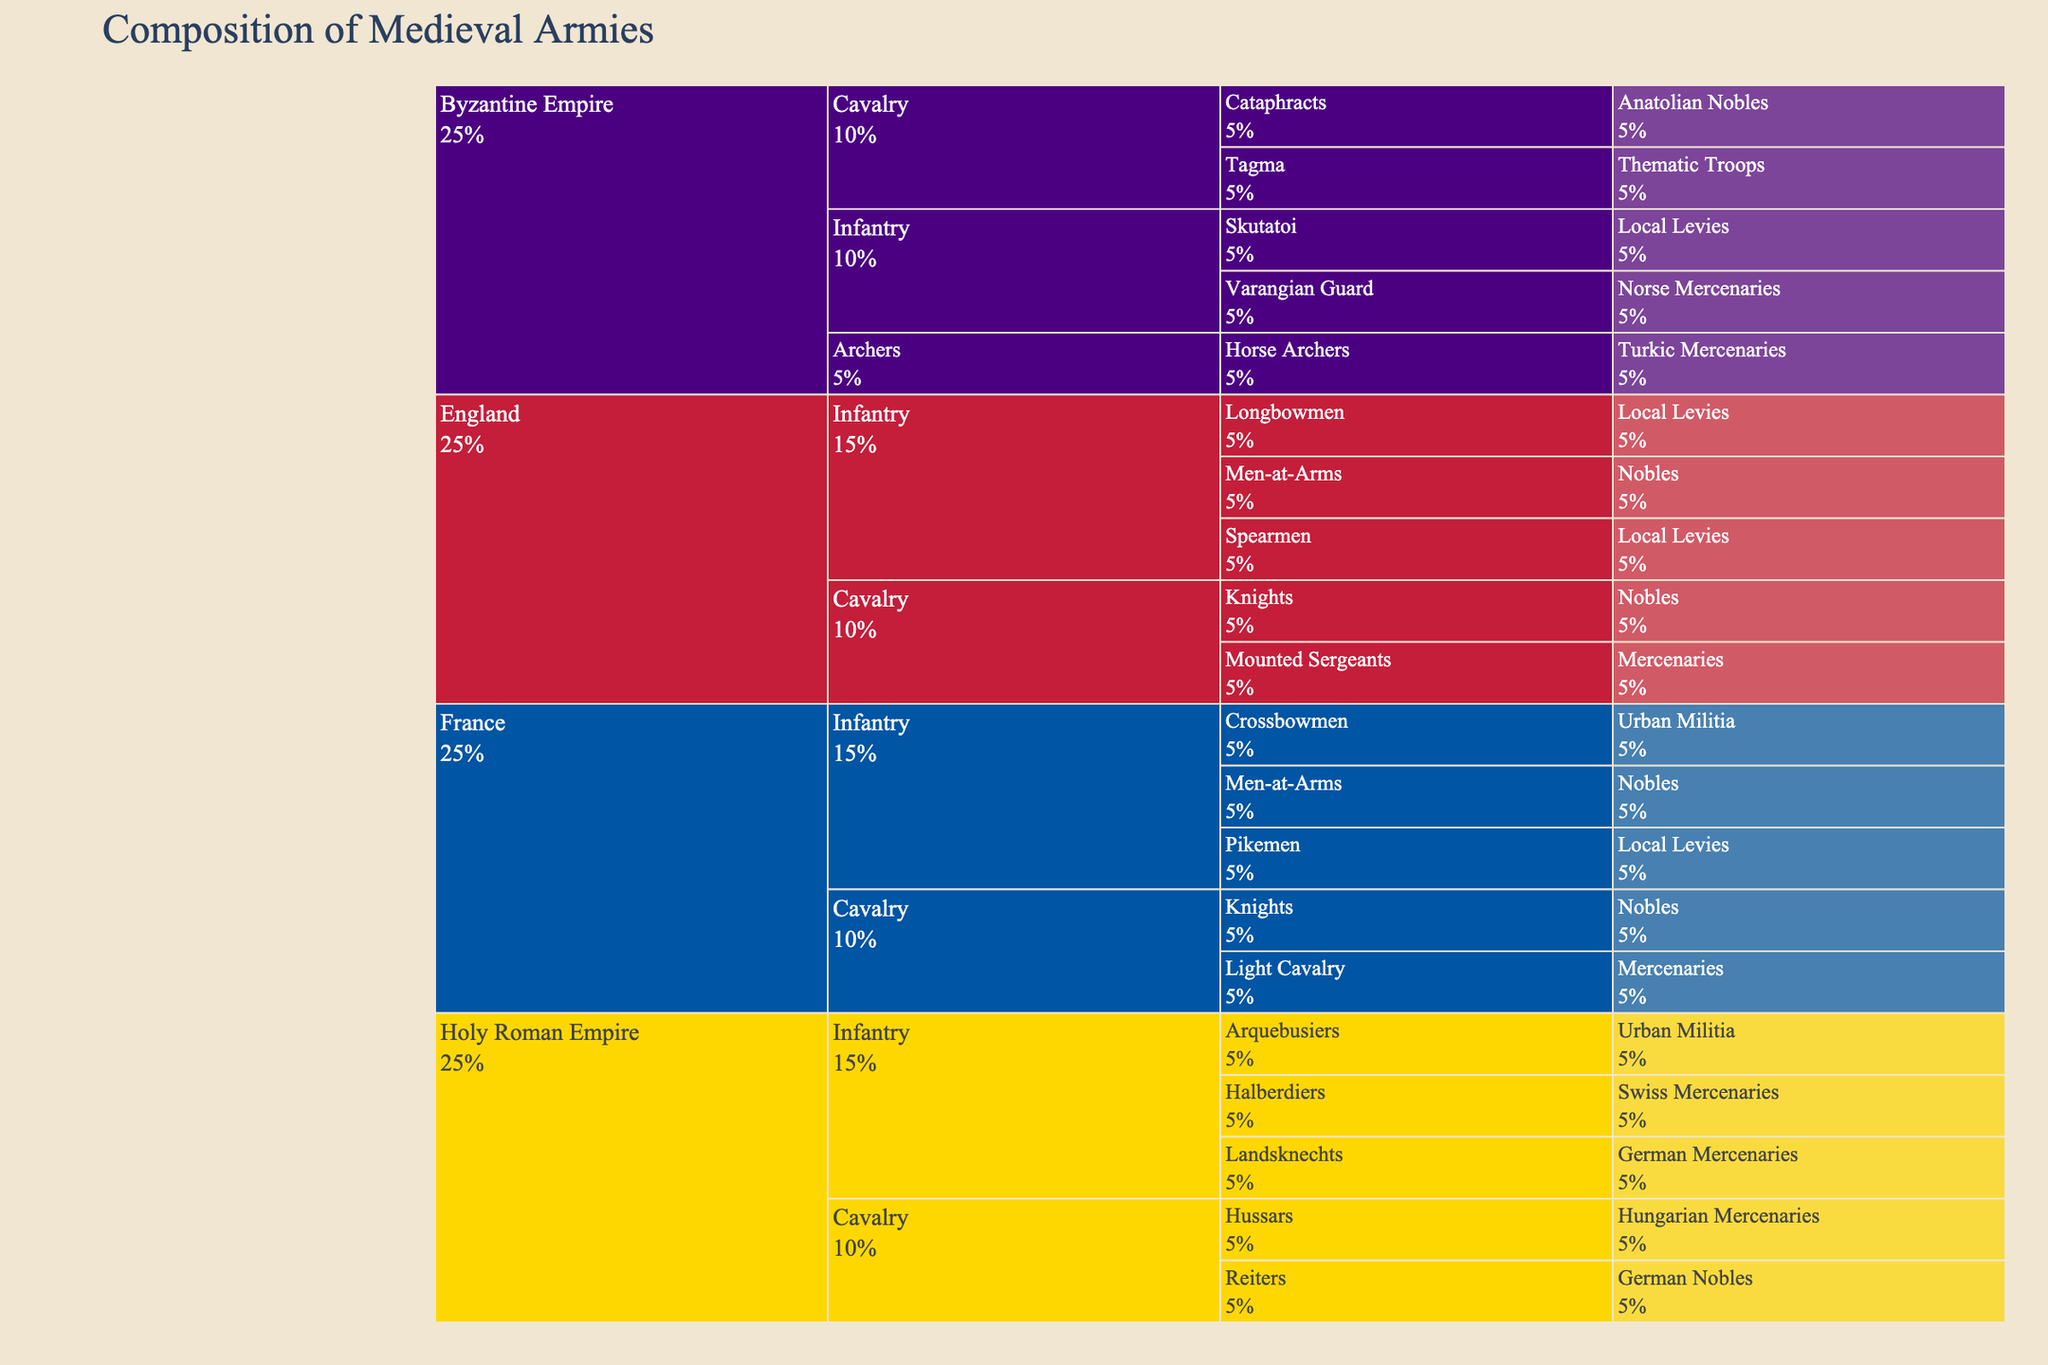What is the title of the Icicle Chart? The title of the chart is usually displayed at the top of the figure and serves as a summary of the data presented.
Answer: Composition of Medieval Armies Which kingdom's army contains the 'Varangian Guard'? By looking at the hierarchical structure of the chart, we find 'Varangian Guard' under 'Byzantine Empire' in the 'Infantry' category.
Answer: Byzantine Empire Name the troop types under the French Cavalry. In the French Cavalry branch, you can identify the troop types by following the hierarchy: 'Knights' and 'Light Cavalry'.
Answer: Knights, Light Cavalry How many troop types are contributed by local levies in total? We need to count all troop types whose origin is 'Local Levies' across all branches. They are 'Longbowmen', 'Spearmen', and 'Pikemen', and 'Skutatoi'.
Answer: 4 Compare the origins of troop types in the English army. Which origin contributes the most? Identify all unique origins within the English hierarchy and count the appearances of each origin. 'Local Levies' appears for 'Longbowmen' and 'Spearmen' contributing 2, 'Nobles' for 'Men-at-Arms' and 'Knights' contributing 2, and 'Mercenaries' for 'Mounted Sergeants' contributing 1. 'Local Levies' and 'Nobles' both contribute the most with 2 each.
Answer: Local Levies and Nobles Which kingdom has the largest variety of troop origins? Examine the color-coded branches corresponding to each kingdom and count the distinct origins. 'Holy Roman Empire' has the origins 'Swiss Mercenaries', 'German Mercenaries', 'Urban Militia', 'German Nobles', 'Hungarian Mercenaries', totaling 5.
Answer: Holy Roman Empire How does the composition of infantry differ between the Byzantine Empire and Holy Roman Empire? Compare the troop types listed under the 'Infantry' category for both kingdoms. Byzantine Empire has 'Varangian Guard', and 'Skutatoi'; Holy Roman Empire has 'Halberdiers', 'Landsknechts', and 'Arquebusiers'.
Answer: Byzantine Empire has 2 types (Varangian Guard, Skutatoi), Holy Roman Empire has 3 types (Halberdiers, Landsknechts, Arquebusiers) What percentage of the Byzantine troops are cavalry? Identify the size of the 'Cavalry' branch in the Byzantine hierarchy and compare it to the total size of the Byzantine branches. The Byzantine army has 'Cavalry (Cataphracts, Tagma)' making up 2 out of 3 branches ('Infantry', 'Cavalry', and 'Archers'), which is approximately 66.7%.
Answer: 66.7% Which troop type in the Holy Roman Empire is unique in its origin compared to other kingdoms? Look through the origins associated with the Holy Roman Empire and compare them with origins in other kingdoms. 'Halberdiers' originated from 'Swiss Mercenaries' which is not found in other kingdoms in this dataset.
Answer: Halberdiers How does the use of mercenaries compare between England and France? Count the instances where the origin is 'Mercenaries' in both England's and France's branches. England has 'Mounted Sergeants' with 1 instance and France has 'Light Cavalry' with 1 instance. Both use mercenaries equally in one troop type each.
Answer: Equal (1 instance each) 